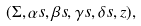Convert formula to latex. <formula><loc_0><loc_0><loc_500><loc_500>( \Sigma , \alpha s , \beta s , \gamma s , \delta s , z ) ,</formula> 